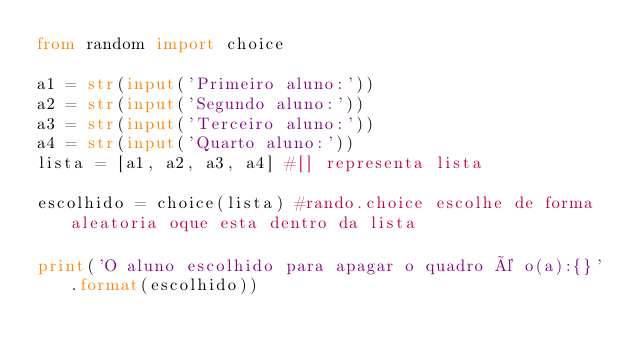Convert code to text. <code><loc_0><loc_0><loc_500><loc_500><_Python_>from random import choice

a1 = str(input('Primeiro aluno:'))
a2 = str(input('Segundo aluno:'))
a3 = str(input('Terceiro aluno:'))
a4 = str(input('Quarto aluno:'))
lista = [a1, a2, a3, a4] #[] representa lista

escolhido = choice(lista) #rando.choice escolhe de forma aleatoria oque esta dentro da lista

print('O aluno escolhido para apagar o quadro é o(a):{}'.format(escolhido))</code> 